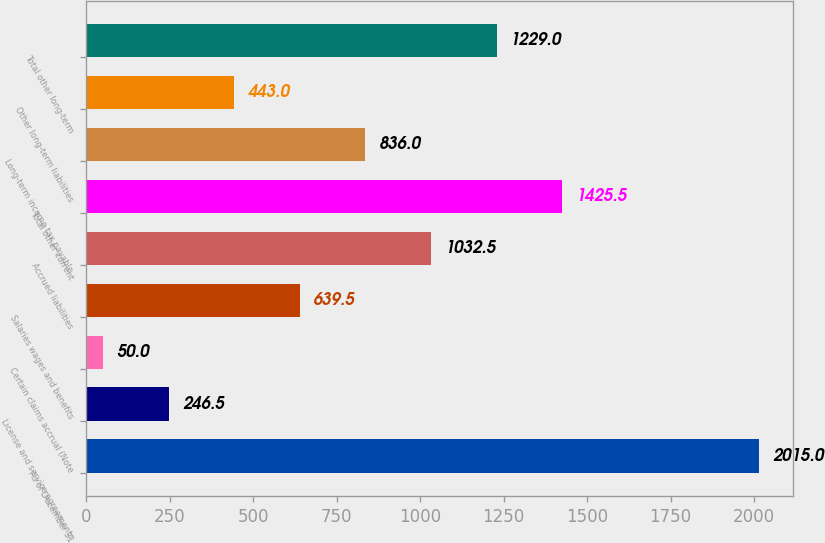Convert chart to OTSL. <chart><loc_0><loc_0><loc_500><loc_500><bar_chart><fcel>As of December 31<fcel>License and service agreements<fcel>Certain claims accrual (Note<fcel>Salaries wages and benefits<fcel>Accrued liabilities<fcel>Total other current<fcel>Long-term income tax payable<fcel>Other long-term liabilities<fcel>Total other long-term<nl><fcel>2015<fcel>246.5<fcel>50<fcel>639.5<fcel>1032.5<fcel>1425.5<fcel>836<fcel>443<fcel>1229<nl></chart> 